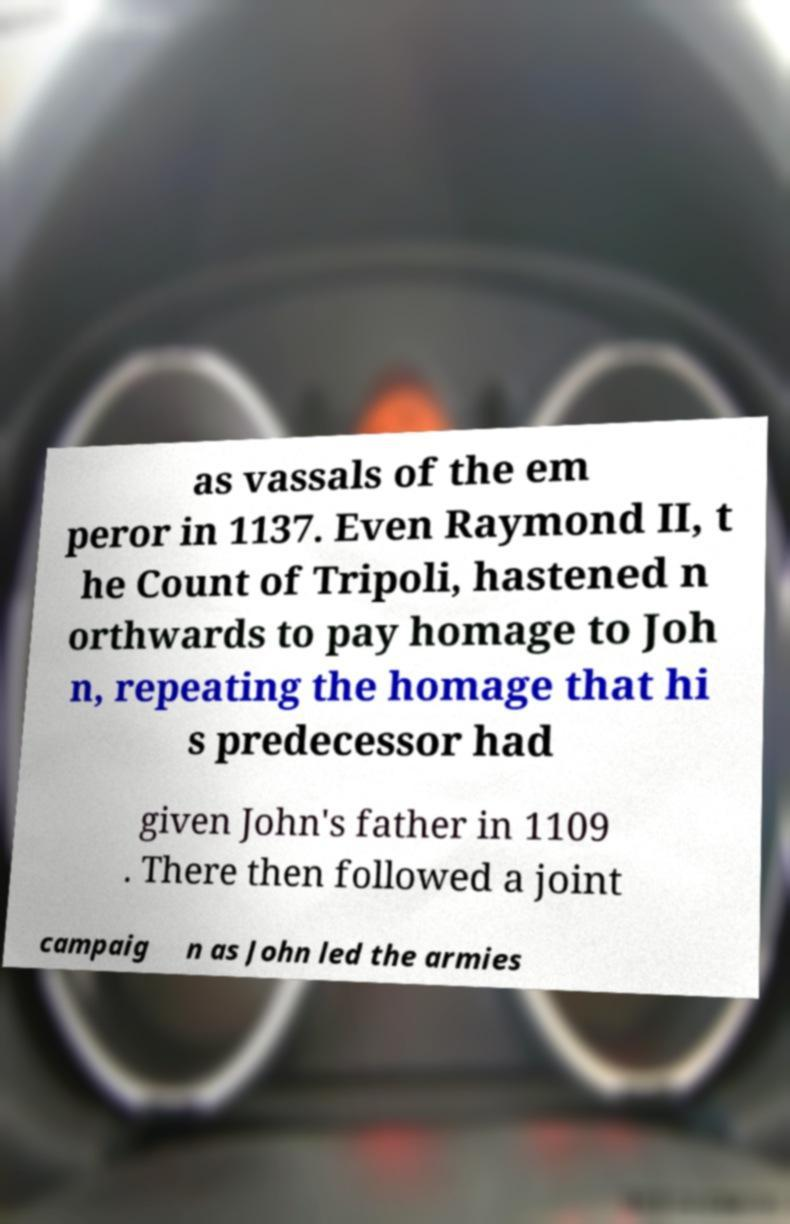I need the written content from this picture converted into text. Can you do that? as vassals of the em peror in 1137. Even Raymond II, t he Count of Tripoli, hastened n orthwards to pay homage to Joh n, repeating the homage that hi s predecessor had given John's father in 1109 . There then followed a joint campaig n as John led the armies 